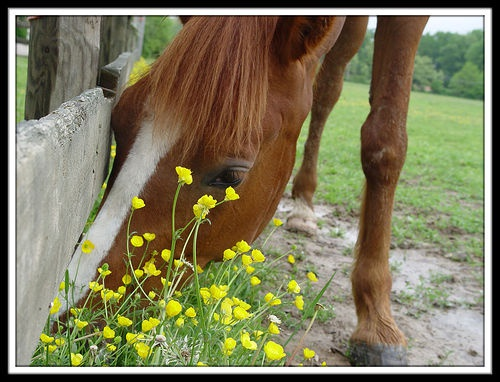Describe the objects in this image and their specific colors. I can see a horse in black, maroon, and gray tones in this image. 